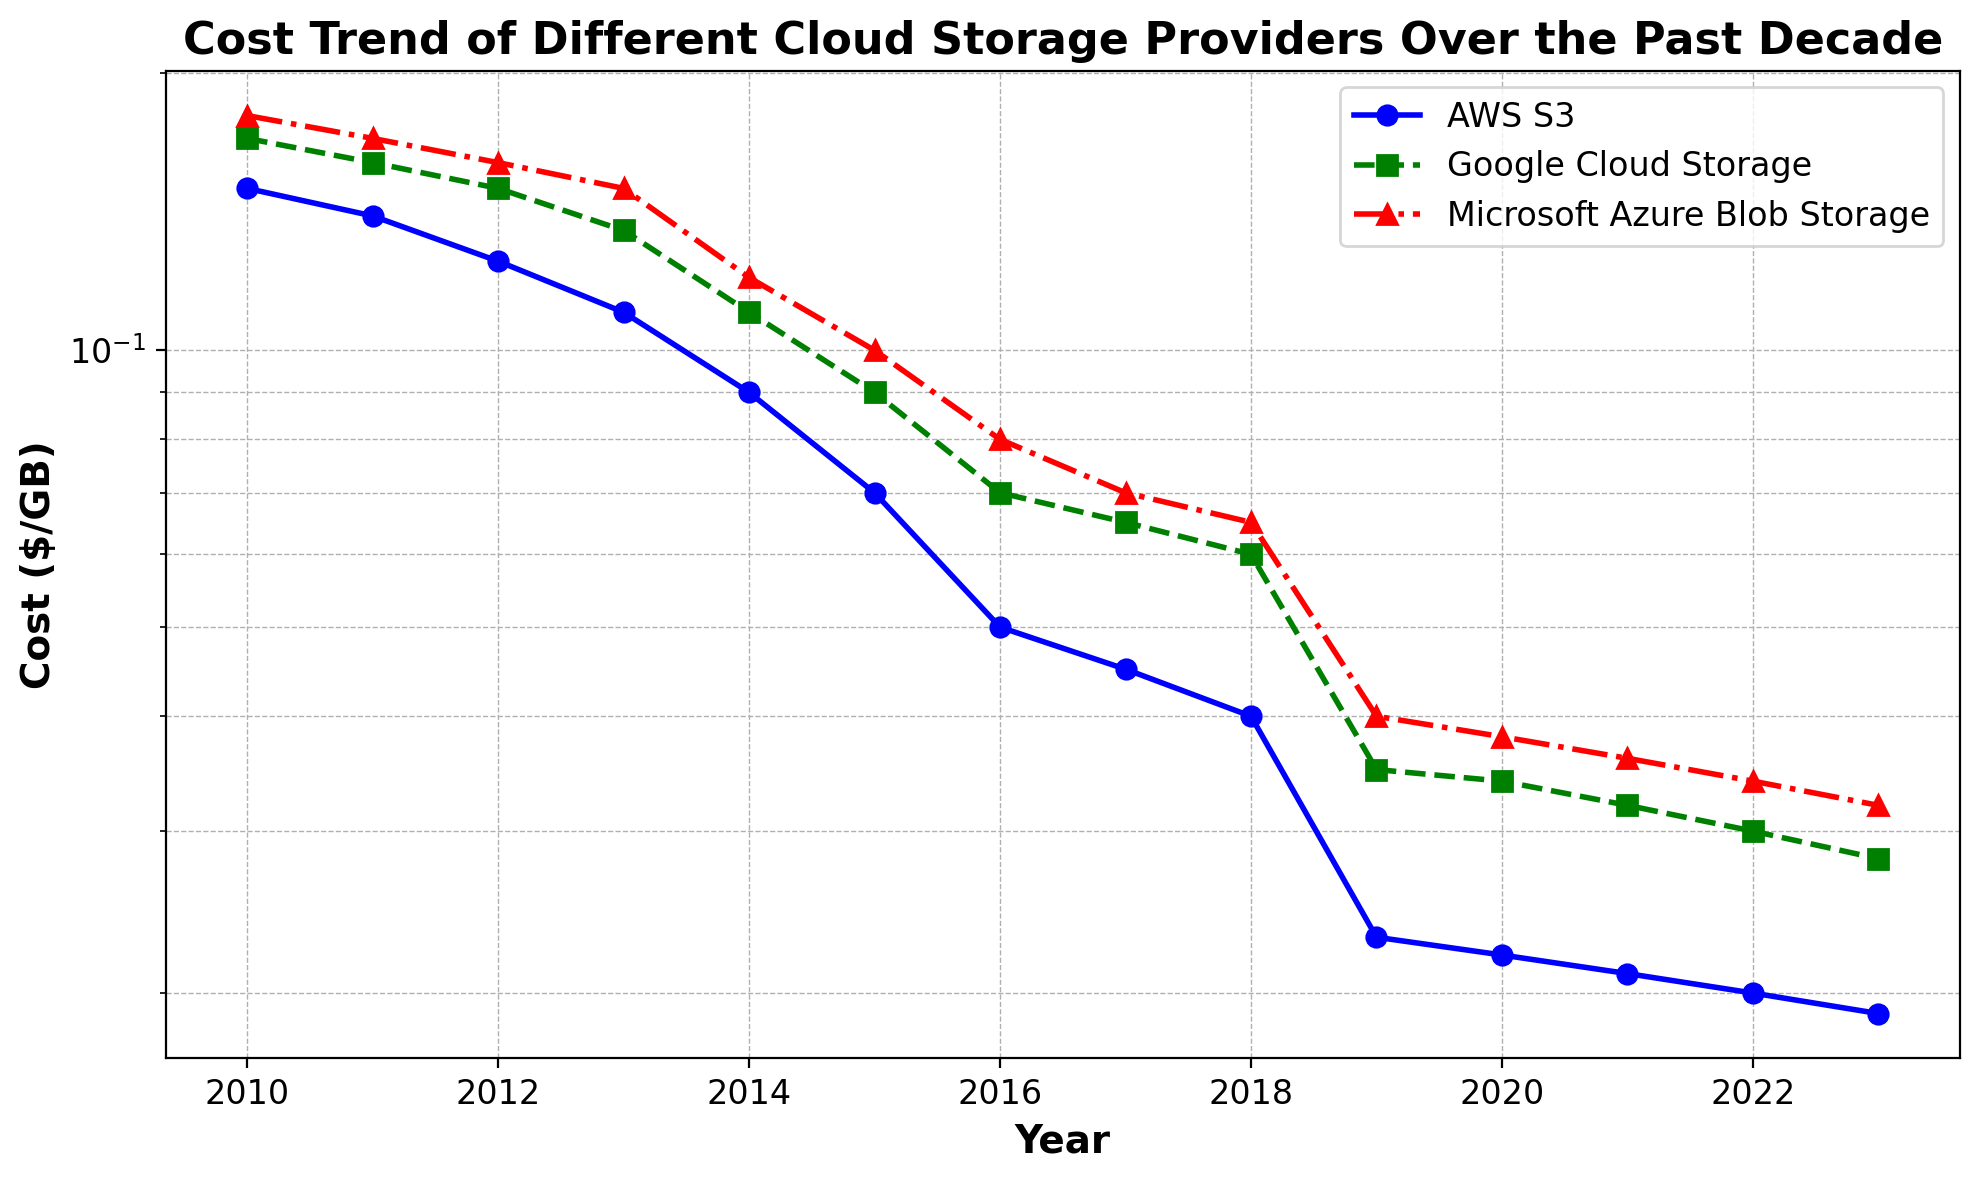How has the cost trend for AWS S3 changed from 2010 to 2023? Look at the blue line representing AWS S3: starting at 0.15 ($/GB) in 2010 and decreasing steadily to 0.019 ($/GB) in 2023. This shows a clear downward trend over the period.
Answer: It has decreased In which year did Microsoft Azure Blob Storage cost significantly drop below $0.10 per GB? Check the red line representing Microsoft Azure Blob Storage and look for the point where it first falls below $0.10 per GB. This occurs between 2014 and 2015 (specifically in 2015).
Answer: 2015 Which cloud storage provider showed the smallest change in cost from 2010 to 2023 according to the plot? Compare the lines for AWS S3 (blue), Google Cloud Storage (green), and Microsoft Azure Blob Storage (red). Google Cloud Storage decreased from 0.17 to 0.028 ($/GB), AWS S3 from 0.15 to 0.019 ($/GB), and Microsoft Azure Blob Storage from 0.18 to 0.032 ($/GB). Google Cloud Storage shows the smallest change.
Answer: Google Cloud Storage Between 2017 and 2023, which cloud storage provider showed the most stable cost trend? Compare the segments of the lines from 2017 to 2023 for all providers. AWS S3 (blue) shows slight decline, Google Cloud Storage (green) a slight decline, and Microsoft Azure Blob Storage (red) a more significant decline. AWS S3 has the most stable trend.
Answer: AWS S3 Which provider had the highest cost in 2023? Look at the endpoints of each line on the plot in 2023. Microsoft's Azure Blob Storage ends at about 0.032 ($/GB), which is the highest among the three providers in that year.
Answer: Microsoft Azure Blob Storage What can be inferred about the cost decline rate of AWS S3 compared to Google Cloud Storage and Microsoft Azure Blob Storage? Analyze the slope of the blue line (AWS S3) versus the green (Google Cloud Storage) and red (Microsoft Azure Blob Storage) lines. AWS S3 shows steeper declines initially but tends to stabilize after 2019, while Google Cloud Storage and Microsoft Azure Blob Storage show steady declines throughout. AWS S3's initial decline is faster.
Answer: Faster initial decline By how much did the cost of Google Cloud Storage decrease from 2010 to 2023? Find the start and end points for Google Cloud Storage (green line): it went from 0.17 in 2010 to 0.028 in 2023. The difference is 0.17 - 0.028 = 0.142 ($/GB).
Answer: 0.142 ($/GB) In which year did all three cloud storage providers show the closest costs to each other? Look for the year where the three lines converge closest together. Around 2014, costs are 0.09 for AWS S3, 0.11 for Google Cloud Storage, and 0.12 for Microsoft Azure Blob Storage — the differences are minimal.
Answer: 2014 